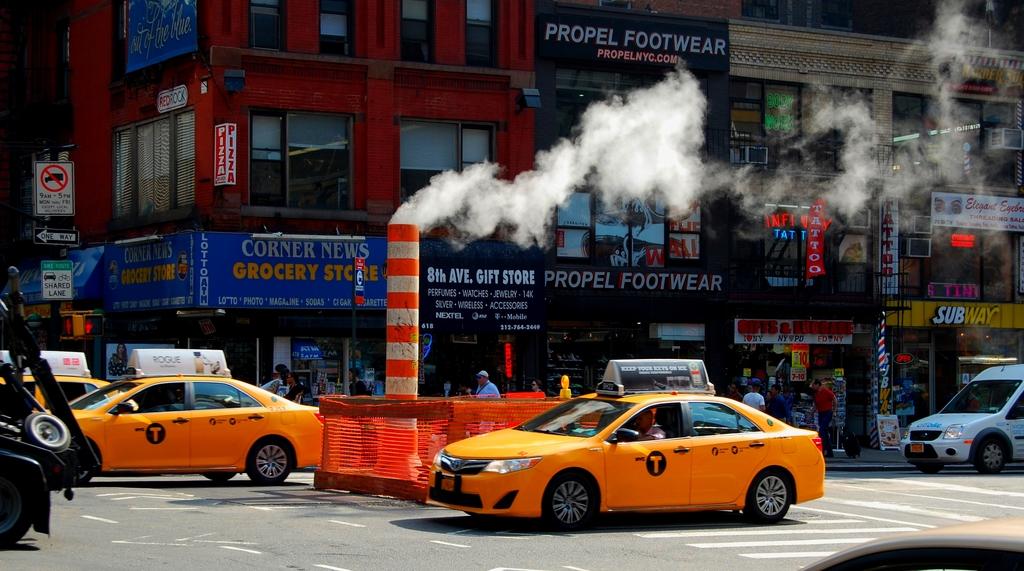What is the footwear store name?
Your response must be concise. Propel. What avenue is this?
Ensure brevity in your answer.  8th. 